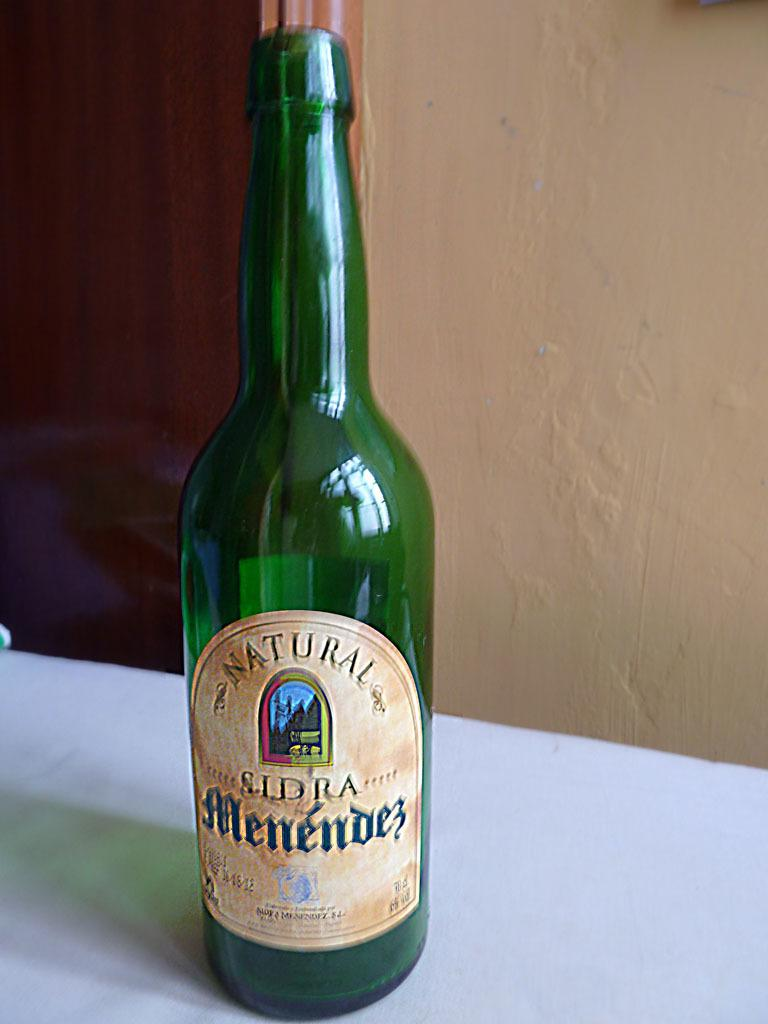<image>
Provide a brief description of the given image. A green bottle of  Natural SIDRA Menendez. 